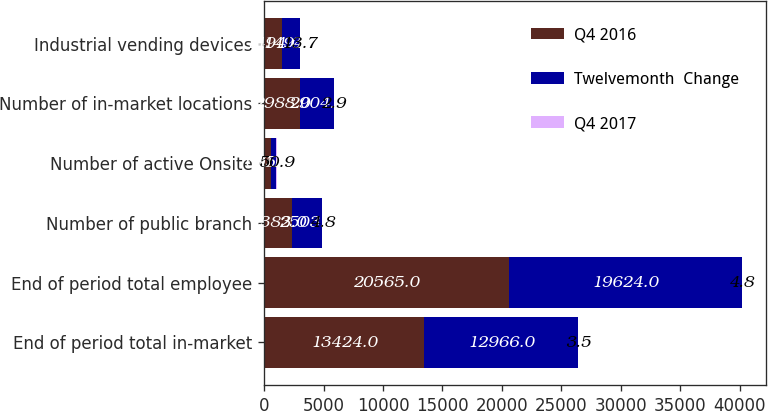<chart> <loc_0><loc_0><loc_500><loc_500><stacked_bar_chart><ecel><fcel>End of period total in-market<fcel>End of period total employee<fcel>Number of public branch<fcel>Number of active Onsite<fcel>Number of in-market locations<fcel>Industrial vending devices<nl><fcel>Q4 2016<fcel>13424<fcel>20565<fcel>2383<fcel>605<fcel>2988<fcel>1494<nl><fcel>Twelvemonth  Change<fcel>12966<fcel>19624<fcel>2503<fcel>401<fcel>2904<fcel>1494<nl><fcel>Q4 2017<fcel>3.5<fcel>4.8<fcel>4.8<fcel>50.9<fcel>2.9<fcel>13.7<nl></chart> 